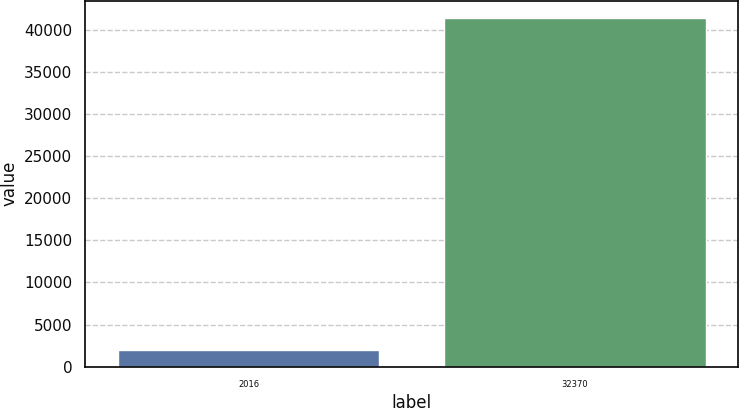Convert chart. <chart><loc_0><loc_0><loc_500><loc_500><bar_chart><fcel>2016<fcel>32370<nl><fcel>2015<fcel>41412<nl></chart> 